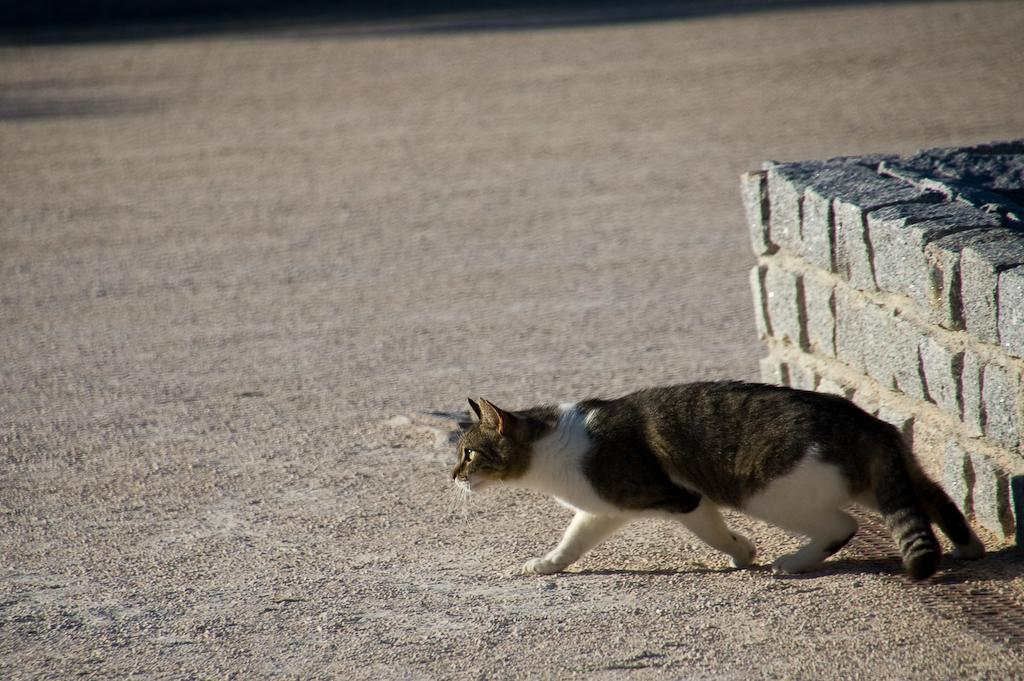What is located on the right side of the image? There is a wall on the right side of the image. What is the main subject in the center of the image? There is a cat in the center of the image. Can you describe the appearance of the cat? The cat is brown and white in color. How would you describe the background of the image? The background of the image is blurred. What type of care does the cat need in the image? There is no indication in the image that the cat needs any care. Can you see a whip being used in the image? There is no whip present in the image. 